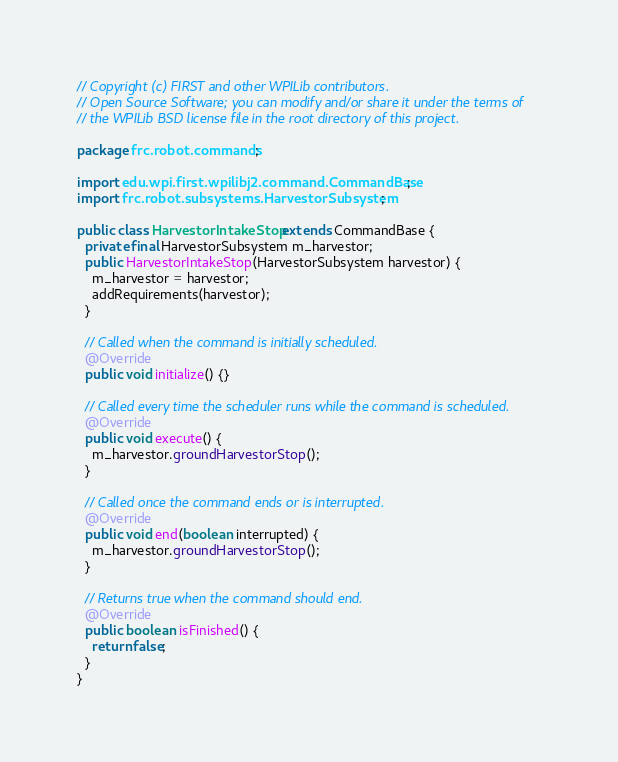<code> <loc_0><loc_0><loc_500><loc_500><_Java_>// Copyright (c) FIRST and other WPILib contributors.
// Open Source Software; you can modify and/or share it under the terms of
// the WPILib BSD license file in the root directory of this project.

package frc.robot.commands;

import edu.wpi.first.wpilibj2.command.CommandBase;
import frc.robot.subsystems.HarvestorSubsystem;

public class HarvestorIntakeStop extends CommandBase {
  private final HarvestorSubsystem m_harvestor;
  public HarvestorIntakeStop(HarvestorSubsystem harvestor) {
    m_harvestor = harvestor;
    addRequirements(harvestor); 
  }

  // Called when the command is initially scheduled.
  @Override
  public void initialize() {}

  // Called every time the scheduler runs while the command is scheduled.
  @Override
  public void execute() {
    m_harvestor.groundHarvestorStop();
  }

  // Called once the command ends or is interrupted.
  @Override
  public void end(boolean interrupted) {
    m_harvestor.groundHarvestorStop();
  }

  // Returns true when the command should end.
  @Override
  public boolean isFinished() {
    return false;
  }
}</code> 